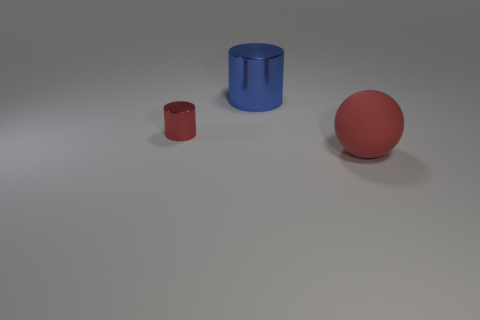There is another small object that is made of the same material as the blue object; what is its color?
Give a very brief answer. Red. Is there a rubber cylinder of the same size as the blue shiny object?
Keep it short and to the point. No. Does the cylinder that is in front of the big cylinder have the same color as the matte object?
Your answer should be compact. Yes. There is a thing that is both behind the red matte sphere and on the right side of the red metallic object; what color is it?
Provide a succinct answer. Blue. What is the shape of the red rubber object that is the same size as the blue thing?
Make the answer very short. Sphere. Are there any red shiny things of the same shape as the blue metal thing?
Offer a terse response. Yes. Is the size of the object that is on the right side of the blue metallic cylinder the same as the blue shiny cylinder?
Make the answer very short. Yes. There is a object that is behind the big red rubber sphere and in front of the blue metallic thing; what size is it?
Offer a terse response. Small. How many other objects are the same material as the small red cylinder?
Offer a very short reply. 1. There is a red thing right of the blue metal cylinder; what size is it?
Your answer should be very brief. Large. 